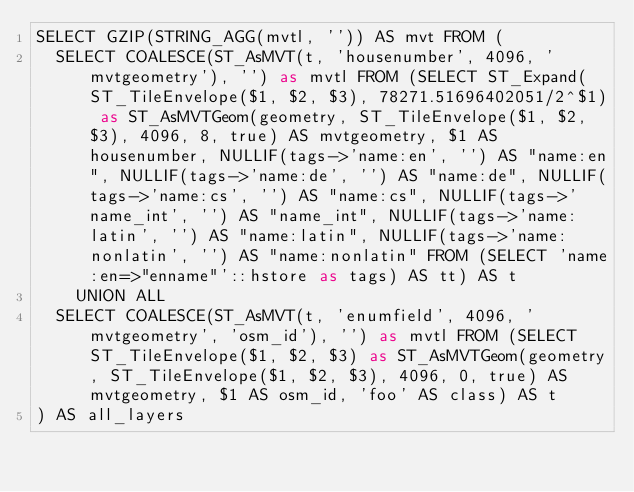Convert code to text. <code><loc_0><loc_0><loc_500><loc_500><_SQL_>SELECT GZIP(STRING_AGG(mvtl, '')) AS mvt FROM (
  SELECT COALESCE(ST_AsMVT(t, 'housenumber', 4096, 'mvtgeometry'), '') as mvtl FROM (SELECT ST_Expand(ST_TileEnvelope($1, $2, $3), 78271.51696402051/2^$1) as ST_AsMVTGeom(geometry, ST_TileEnvelope($1, $2, $3), 4096, 8, true) AS mvtgeometry, $1 AS housenumber, NULLIF(tags->'name:en', '') AS "name:en", NULLIF(tags->'name:de', '') AS "name:de", NULLIF(tags->'name:cs', '') AS "name:cs", NULLIF(tags->'name_int', '') AS "name_int", NULLIF(tags->'name:latin', '') AS "name:latin", NULLIF(tags->'name:nonlatin', '') AS "name:nonlatin" FROM (SELECT 'name:en=>"enname"'::hstore as tags) AS tt) AS t
    UNION ALL
  SELECT COALESCE(ST_AsMVT(t, 'enumfield', 4096, 'mvtgeometry', 'osm_id'), '') as mvtl FROM (SELECT ST_TileEnvelope($1, $2, $3) as ST_AsMVTGeom(geometry, ST_TileEnvelope($1, $2, $3), 4096, 0, true) AS mvtgeometry, $1 AS osm_id, 'foo' AS class) AS t
) AS all_layers

</code> 